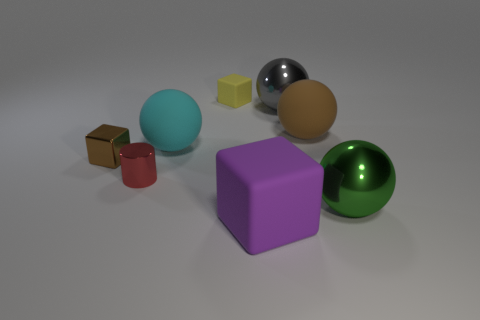Is there a tiny red object that has the same shape as the purple thing?
Ensure brevity in your answer.  No. What material is the ball that is the same color as the tiny shiny block?
Give a very brief answer. Rubber. What number of matte things are either tiny yellow objects or tiny red cylinders?
Give a very brief answer. 1. What is the shape of the tiny brown metallic thing?
Provide a short and direct response. Cube. How many brown cylinders have the same material as the big cyan thing?
Make the answer very short. 0. There is a block that is made of the same material as the big purple thing; what is its color?
Provide a short and direct response. Yellow. Is the size of the cube that is to the left of the red cylinder the same as the yellow matte block?
Make the answer very short. Yes. There is another rubber object that is the same shape as the purple object; what is its color?
Make the answer very short. Yellow. There is a thing that is on the right side of the big matte object right of the large block to the right of the cyan sphere; what shape is it?
Give a very brief answer. Sphere. Do the big gray object and the green metal object have the same shape?
Your response must be concise. Yes. 